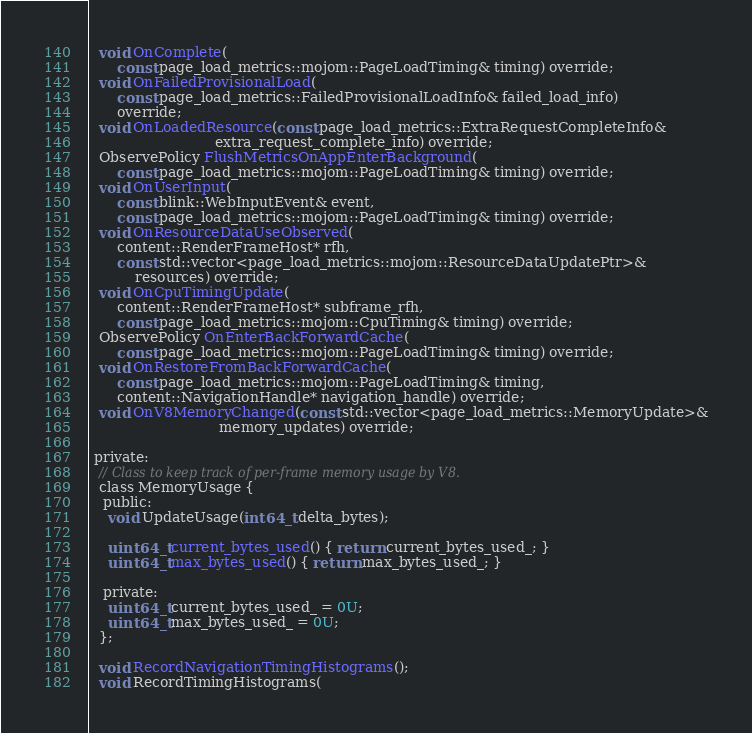Convert code to text. <code><loc_0><loc_0><loc_500><loc_500><_C_>  void OnComplete(
      const page_load_metrics::mojom::PageLoadTiming& timing) override;
  void OnFailedProvisionalLoad(
      const page_load_metrics::FailedProvisionalLoadInfo& failed_load_info)
      override;
  void OnLoadedResource(const page_load_metrics::ExtraRequestCompleteInfo&
                            extra_request_complete_info) override;
  ObservePolicy FlushMetricsOnAppEnterBackground(
      const page_load_metrics::mojom::PageLoadTiming& timing) override;
  void OnUserInput(
      const blink::WebInputEvent& event,
      const page_load_metrics::mojom::PageLoadTiming& timing) override;
  void OnResourceDataUseObserved(
      content::RenderFrameHost* rfh,
      const std::vector<page_load_metrics::mojom::ResourceDataUpdatePtr>&
          resources) override;
  void OnCpuTimingUpdate(
      content::RenderFrameHost* subframe_rfh,
      const page_load_metrics::mojom::CpuTiming& timing) override;
  ObservePolicy OnEnterBackForwardCache(
      const page_load_metrics::mojom::PageLoadTiming& timing) override;
  void OnRestoreFromBackForwardCache(
      const page_load_metrics::mojom::PageLoadTiming& timing,
      content::NavigationHandle* navigation_handle) override;
  void OnV8MemoryChanged(const std::vector<page_load_metrics::MemoryUpdate>&
                             memory_updates) override;

 private:
  // Class to keep track of per-frame memory usage by V8.
  class MemoryUsage {
   public:
    void UpdateUsage(int64_t delta_bytes);

    uint64_t current_bytes_used() { return current_bytes_used_; }
    uint64_t max_bytes_used() { return max_bytes_used_; }

   private:
    uint64_t current_bytes_used_ = 0U;
    uint64_t max_bytes_used_ = 0U;
  };

  void RecordNavigationTimingHistograms();
  void RecordTimingHistograms(</code> 